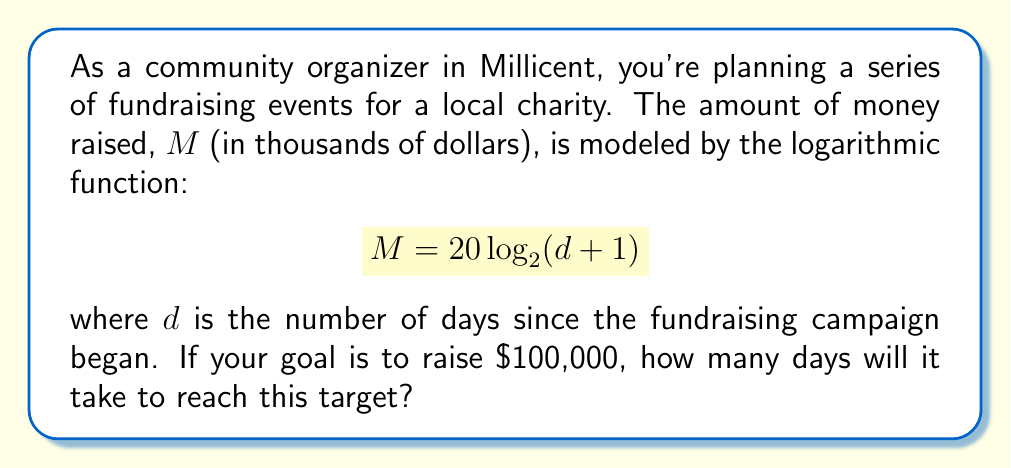Give your solution to this math problem. Let's approach this step-by-step:

1) We need to find $d$ when $M = 100$, as $100,000 is represented as 100 in our equation (remember, $M$ is in thousands of dollars).

2) Substitute $M = 100$ into the equation:
   $$100 = 20 \log_2(d + 1)$$

3) Divide both sides by 20:
   $$5 = \log_2(d + 1)$$

4) To solve for $d$, we need to apply the inverse function (exponential) to both sides:
   $$2^5 = d + 1$$

5) Calculate $2^5$:
   $$32 = d + 1$$

6) Subtract 1 from both sides:
   $$31 = d$$

Therefore, it will take 31 days to reach the fundraising goal of $100,000.
Answer: 31 days 